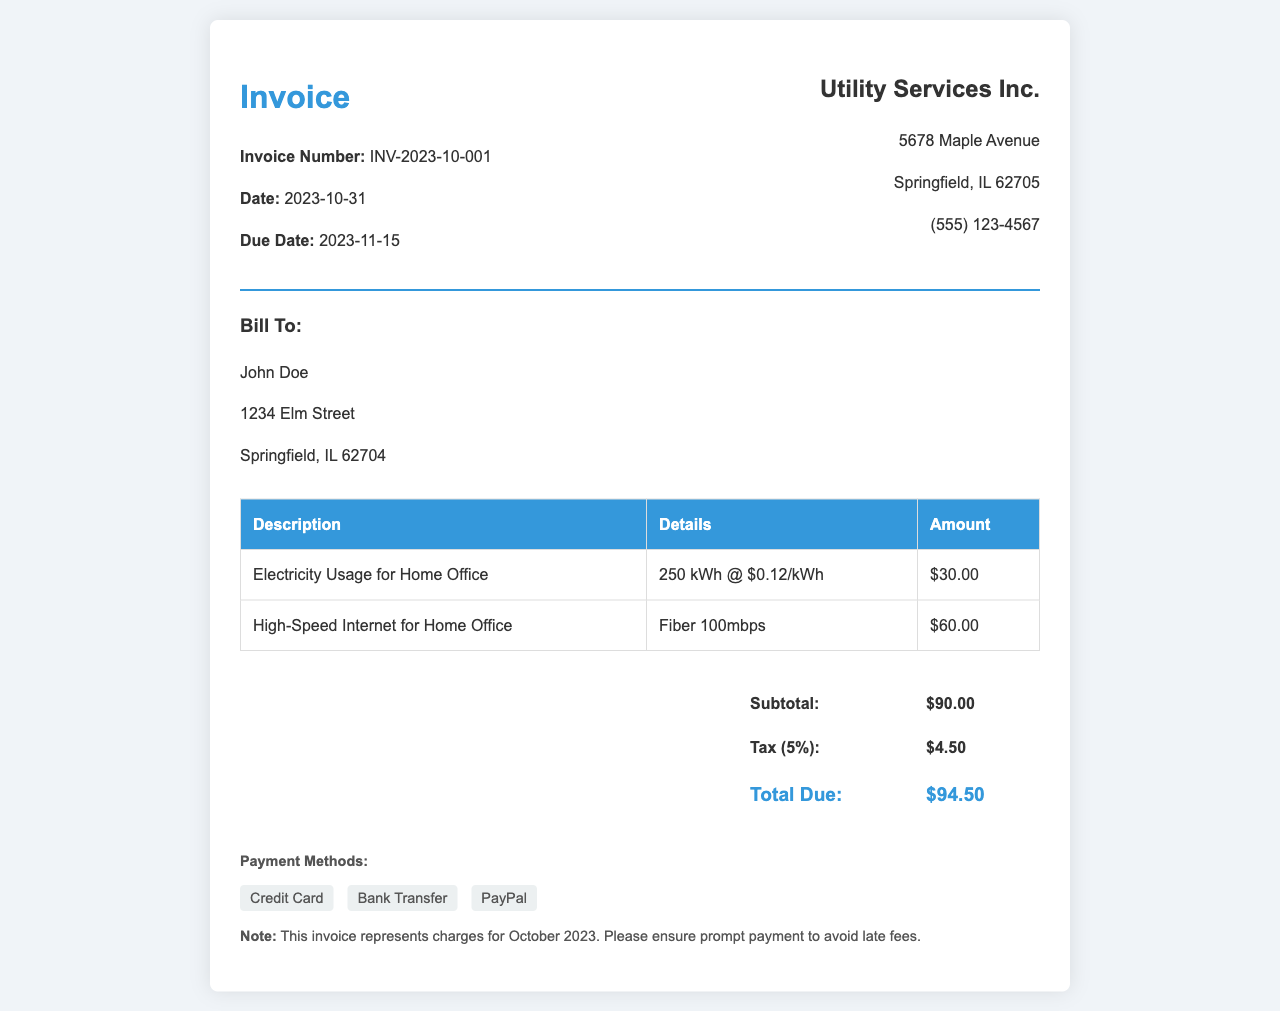What is the invoice number? The invoice number is indicated at the top of the document and is a unique identifier for this invoice.
Answer: INV-2023-10-001 What is the total due amount? The total amount due is calculated including subtotal and tax, shown at the bottom of the invoice.
Answer: $94.50 Who is the bill recipient? The name of the individual or entity being billed is provided in the 'Bill To' section.
Answer: John Doe What is the electricity charge amount? The specific charge for electricity usage is listed in the invoice table under the 'Amount' column.
Answer: $30.00 What percentage is the tax applied? The tax rate is mentioned in the totals section of the invoice.
Answer: 5% How much was charged for internet services? The amount charged for high-speed internet is presented in the invoice table.
Answer: $60.00 When is the due date for payment? The due date is provided in the invoice header section, indicating when payment should be made.
Answer: 2023-11-15 What is the subtotal before tax? The subtotal is given in the totals section of the invoice, which is the sum of all amounts before tax.
Answer: $90.00 What payment methods are accepted? The payment methods are listed in the 'Payment Methods' section at the end of the invoice.
Answer: Credit Card, Bank Transfer, PayPal 